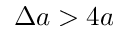Convert formula to latex. <formula><loc_0><loc_0><loc_500><loc_500>\Delta a > 4 a</formula> 